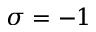<formula> <loc_0><loc_0><loc_500><loc_500>\sigma = - 1</formula> 